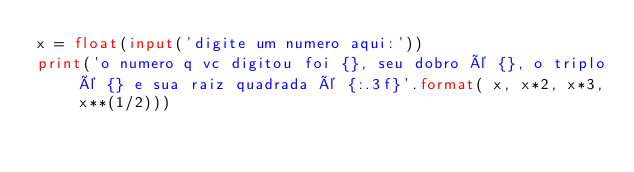Convert code to text. <code><loc_0><loc_0><loc_500><loc_500><_Python_>x = float(input('digite um numero aqui:'))
print('o numero q vc digitou foi {}, seu dobro é {}, o triplo é {} e sua raiz quadrada é {:.3f}'.format( x, x*2, x*3, x**(1/2)))
</code> 